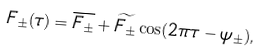<formula> <loc_0><loc_0><loc_500><loc_500>F _ { \pm } ( \tau ) = \overline { F _ { \pm } } + \widetilde { F _ { \pm } } \cos ( 2 \pi \tau - \psi _ { \pm } ) ,</formula> 